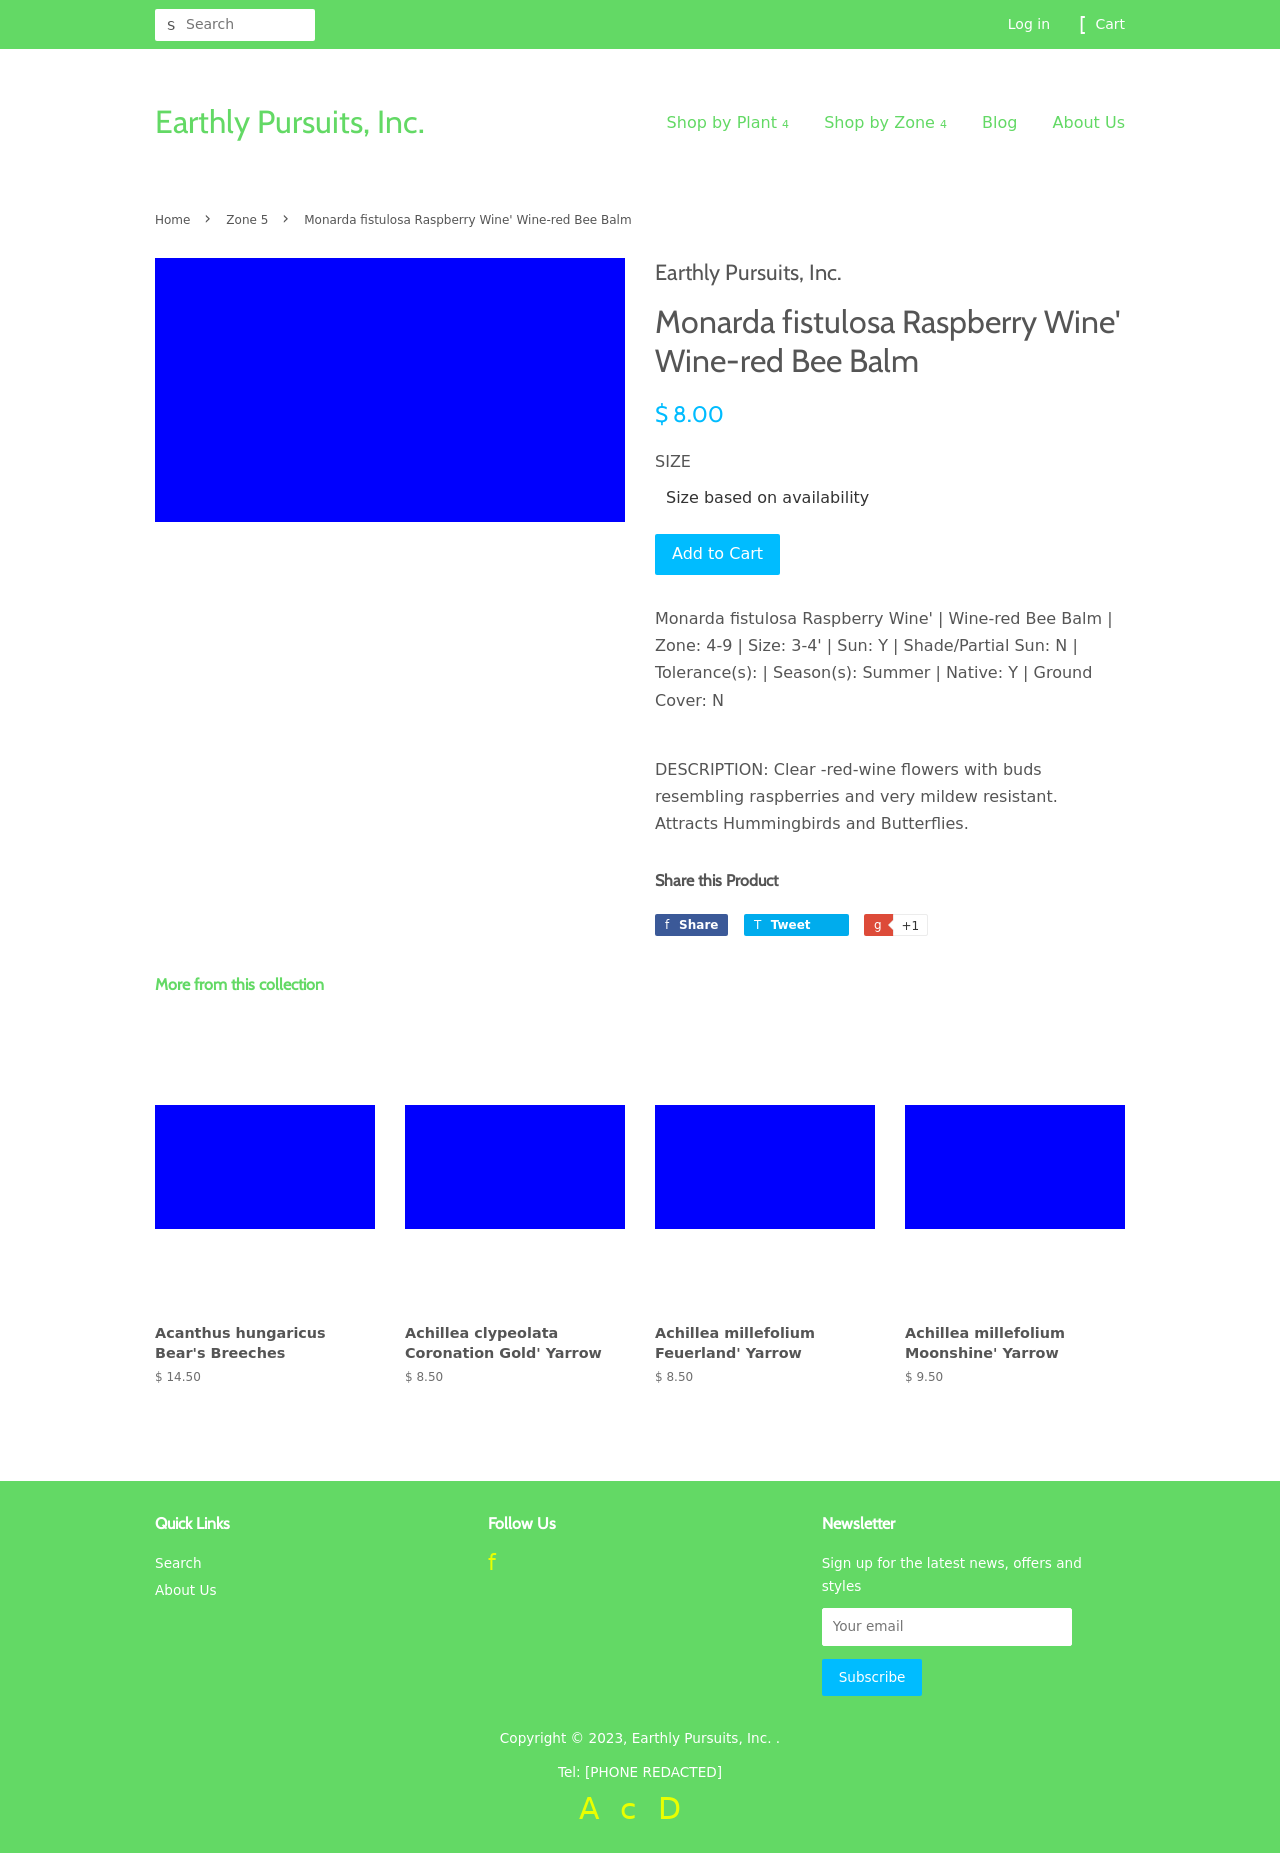Can you describe the main elements visible on this web page related to the plant shop? This web page displays information about a specific plant called 'Monarda fistulosa Raspberry Wine,' which is a type of Wine-red Bee Balm. Key elements include the plant's price, size availability, and a brief description highlighting its allure, such as attracting hummingbirds and being mildew resistant. Additionally, there are navigation links to shop by plant type or by zone, and links to other sections like a blog and about us. Thumbnails below suggest more plants from the collection, each with names and prices shown.  What user interactions can be done on this page? Users can interact with the page in several ways including navigating through the plant categories via the top menu, adding the Wine-red Bee Balm to their cart, choosing different plant varieties from the collection shown at the bottom, and subscribing to a newsletter through the footer section. The top right corner also allows for user login or cart review, enhancing the ecommerce functionality of the site. 